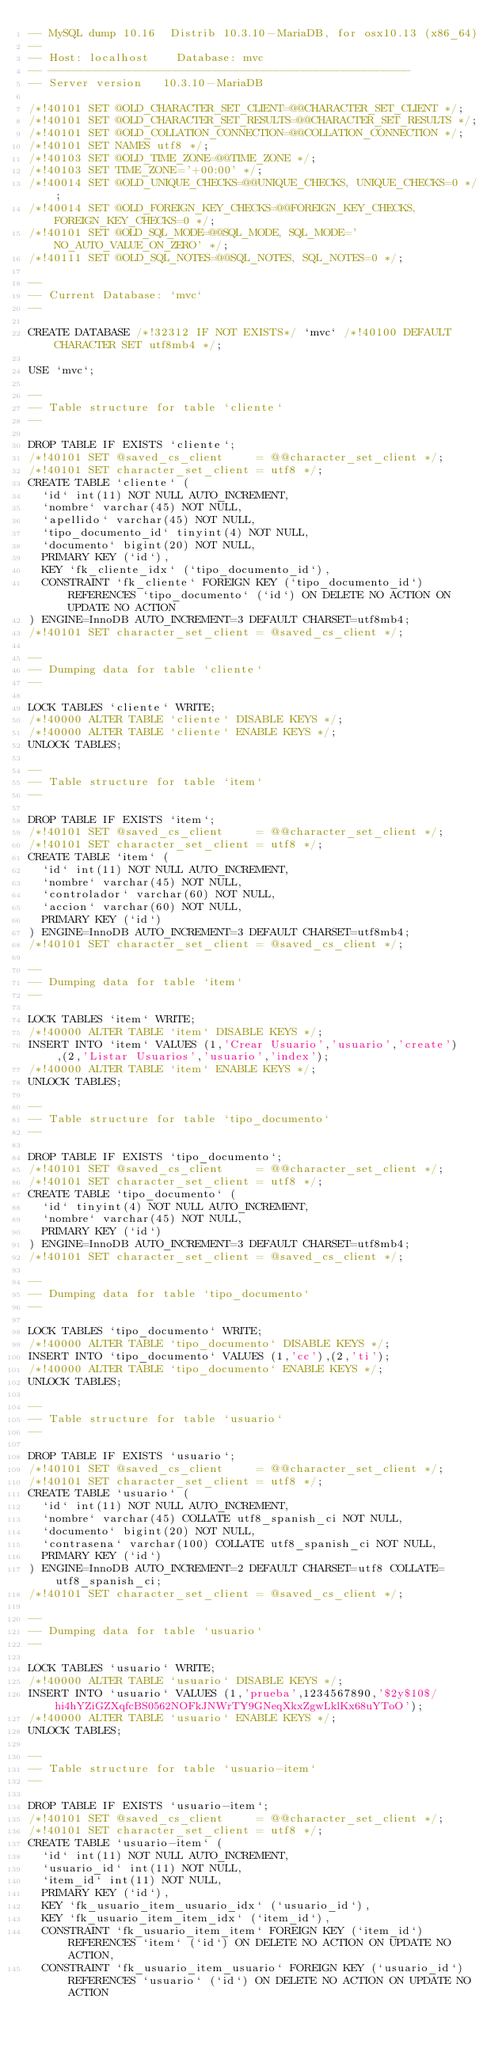Convert code to text. <code><loc_0><loc_0><loc_500><loc_500><_SQL_>-- MySQL dump 10.16  Distrib 10.3.10-MariaDB, for osx10.13 (x86_64)
--
-- Host: localhost    Database: mvc
-- ------------------------------------------------------
-- Server version	10.3.10-MariaDB

/*!40101 SET @OLD_CHARACTER_SET_CLIENT=@@CHARACTER_SET_CLIENT */;
/*!40101 SET @OLD_CHARACTER_SET_RESULTS=@@CHARACTER_SET_RESULTS */;
/*!40101 SET @OLD_COLLATION_CONNECTION=@@COLLATION_CONNECTION */;
/*!40101 SET NAMES utf8 */;
/*!40103 SET @OLD_TIME_ZONE=@@TIME_ZONE */;
/*!40103 SET TIME_ZONE='+00:00' */;
/*!40014 SET @OLD_UNIQUE_CHECKS=@@UNIQUE_CHECKS, UNIQUE_CHECKS=0 */;
/*!40014 SET @OLD_FOREIGN_KEY_CHECKS=@@FOREIGN_KEY_CHECKS, FOREIGN_KEY_CHECKS=0 */;
/*!40101 SET @OLD_SQL_MODE=@@SQL_MODE, SQL_MODE='NO_AUTO_VALUE_ON_ZERO' */;
/*!40111 SET @OLD_SQL_NOTES=@@SQL_NOTES, SQL_NOTES=0 */;

--
-- Current Database: `mvc`
--

CREATE DATABASE /*!32312 IF NOT EXISTS*/ `mvc` /*!40100 DEFAULT CHARACTER SET utf8mb4 */;

USE `mvc`;

--
-- Table structure for table `cliente`
--

DROP TABLE IF EXISTS `cliente`;
/*!40101 SET @saved_cs_client     = @@character_set_client */;
/*!40101 SET character_set_client = utf8 */;
CREATE TABLE `cliente` (
  `id` int(11) NOT NULL AUTO_INCREMENT,
  `nombre` varchar(45) NOT NULL,
  `apellido` varchar(45) NOT NULL,
  `tipo_documento_id` tinyint(4) NOT NULL,
  `documento` bigint(20) NOT NULL,
  PRIMARY KEY (`id`),
  KEY `fk_cliente_idx` (`tipo_documento_id`),
  CONSTRAINT `fk_cliente` FOREIGN KEY (`tipo_documento_id`) REFERENCES `tipo_documento` (`id`) ON DELETE NO ACTION ON UPDATE NO ACTION
) ENGINE=InnoDB AUTO_INCREMENT=3 DEFAULT CHARSET=utf8mb4;
/*!40101 SET character_set_client = @saved_cs_client */;

--
-- Dumping data for table `cliente`
--

LOCK TABLES `cliente` WRITE;
/*!40000 ALTER TABLE `cliente` DISABLE KEYS */;
/*!40000 ALTER TABLE `cliente` ENABLE KEYS */;
UNLOCK TABLES;

--
-- Table structure for table `item`
--

DROP TABLE IF EXISTS `item`;
/*!40101 SET @saved_cs_client     = @@character_set_client */;
/*!40101 SET character_set_client = utf8 */;
CREATE TABLE `item` (
  `id` int(11) NOT NULL AUTO_INCREMENT,
  `nombre` varchar(45) NOT NULL,
  `controlador` varchar(60) NOT NULL,
  `accion` varchar(60) NOT NULL,
  PRIMARY KEY (`id`)
) ENGINE=InnoDB AUTO_INCREMENT=3 DEFAULT CHARSET=utf8mb4;
/*!40101 SET character_set_client = @saved_cs_client */;

--
-- Dumping data for table `item`
--

LOCK TABLES `item` WRITE;
/*!40000 ALTER TABLE `item` DISABLE KEYS */;
INSERT INTO `item` VALUES (1,'Crear Usuario','usuario','create'),(2,'Listar Usuarios','usuario','index');
/*!40000 ALTER TABLE `item` ENABLE KEYS */;
UNLOCK TABLES;

--
-- Table structure for table `tipo_documento`
--

DROP TABLE IF EXISTS `tipo_documento`;
/*!40101 SET @saved_cs_client     = @@character_set_client */;
/*!40101 SET character_set_client = utf8 */;
CREATE TABLE `tipo_documento` (
  `id` tinyint(4) NOT NULL AUTO_INCREMENT,
  `nombre` varchar(45) NOT NULL,
  PRIMARY KEY (`id`)
) ENGINE=InnoDB AUTO_INCREMENT=3 DEFAULT CHARSET=utf8mb4;
/*!40101 SET character_set_client = @saved_cs_client */;

--
-- Dumping data for table `tipo_documento`
--

LOCK TABLES `tipo_documento` WRITE;
/*!40000 ALTER TABLE `tipo_documento` DISABLE KEYS */;
INSERT INTO `tipo_documento` VALUES (1,'cc'),(2,'ti');
/*!40000 ALTER TABLE `tipo_documento` ENABLE KEYS */;
UNLOCK TABLES;

--
-- Table structure for table `usuario`
--

DROP TABLE IF EXISTS `usuario`;
/*!40101 SET @saved_cs_client     = @@character_set_client */;
/*!40101 SET character_set_client = utf8 */;
CREATE TABLE `usuario` (
  `id` int(11) NOT NULL AUTO_INCREMENT,
  `nombre` varchar(45) COLLATE utf8_spanish_ci NOT NULL,
  `documento` bigint(20) NOT NULL,
  `contrasena` varchar(100) COLLATE utf8_spanish_ci NOT NULL,
  PRIMARY KEY (`id`)
) ENGINE=InnoDB AUTO_INCREMENT=2 DEFAULT CHARSET=utf8 COLLATE=utf8_spanish_ci;
/*!40101 SET character_set_client = @saved_cs_client */;

--
-- Dumping data for table `usuario`
--

LOCK TABLES `usuario` WRITE;
/*!40000 ALTER TABLE `usuario` DISABLE KEYS */;
INSERT INTO `usuario` VALUES (1,'prueba',1234567890,'$2y$10$/hi4hYZiGZXqfcBS0562NOFkJNWrTY9GNeqXkxZgwLklKx68uYToO');
/*!40000 ALTER TABLE `usuario` ENABLE KEYS */;
UNLOCK TABLES;

--
-- Table structure for table `usuario-item`
--

DROP TABLE IF EXISTS `usuario-item`;
/*!40101 SET @saved_cs_client     = @@character_set_client */;
/*!40101 SET character_set_client = utf8 */;
CREATE TABLE `usuario-item` (
  `id` int(11) NOT NULL AUTO_INCREMENT,
  `usuario_id` int(11) NOT NULL,
  `item_id` int(11) NOT NULL,
  PRIMARY KEY (`id`),
  KEY `fk_usuario_item_usuario_idx` (`usuario_id`),
  KEY `fk_usuario_item_item_idx` (`item_id`),
  CONSTRAINT `fk_usuario_item_item` FOREIGN KEY (`item_id`) REFERENCES `item` (`id`) ON DELETE NO ACTION ON UPDATE NO ACTION,
  CONSTRAINT `fk_usuario_item_usuario` FOREIGN KEY (`usuario_id`) REFERENCES `usuario` (`id`) ON DELETE NO ACTION ON UPDATE NO ACTION</code> 